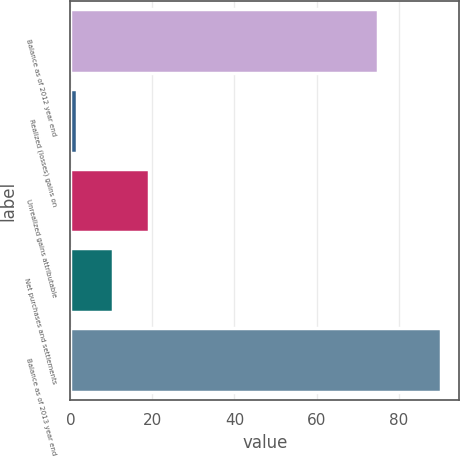Convert chart. <chart><loc_0><loc_0><loc_500><loc_500><bar_chart><fcel>Balance as of 2012 year end<fcel>Realized (losses) gains on<fcel>Unrealized gains attributable<fcel>Net purchases and settlements<fcel>Balance as of 2013 year end<nl><fcel>75<fcel>1.5<fcel>19.26<fcel>10.38<fcel>90.3<nl></chart> 